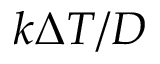Convert formula to latex. <formula><loc_0><loc_0><loc_500><loc_500>k \Delta T / D</formula> 